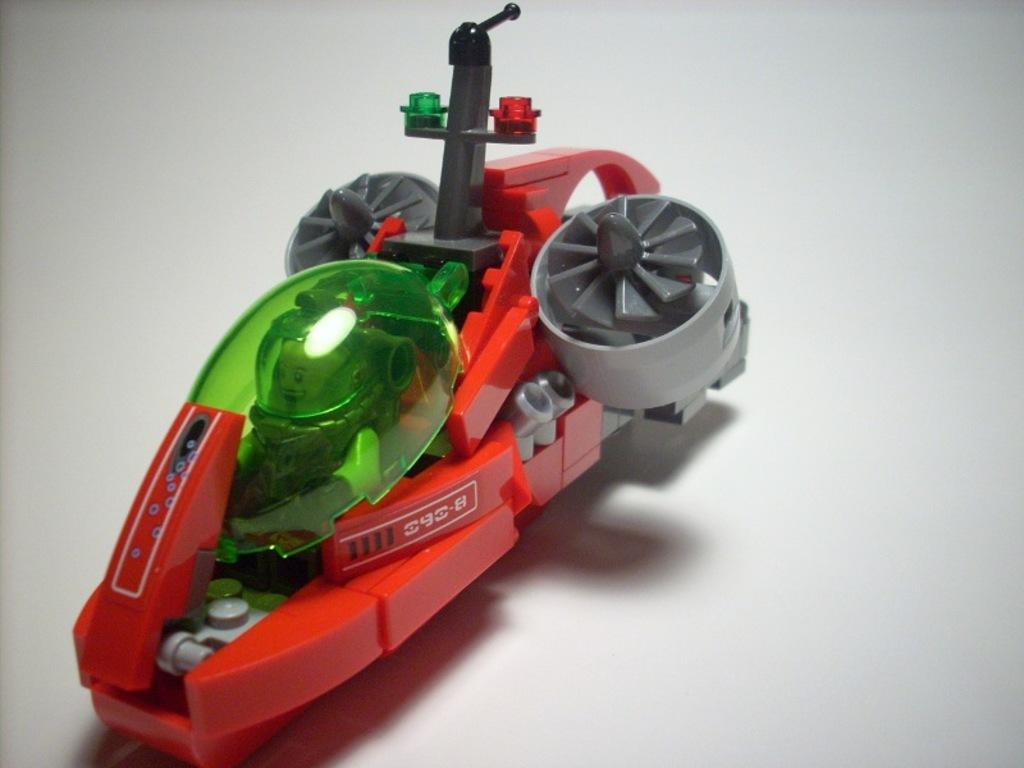What color is the toy that is visible in the image? The toy in the image is red. What is the toy placed on in the image? The red toy is on a white surface. Can you see a kitty playing with trains on the white surface in the image? No, there is no kitty or trains present in the image; it only features a red toy on a white surface. 